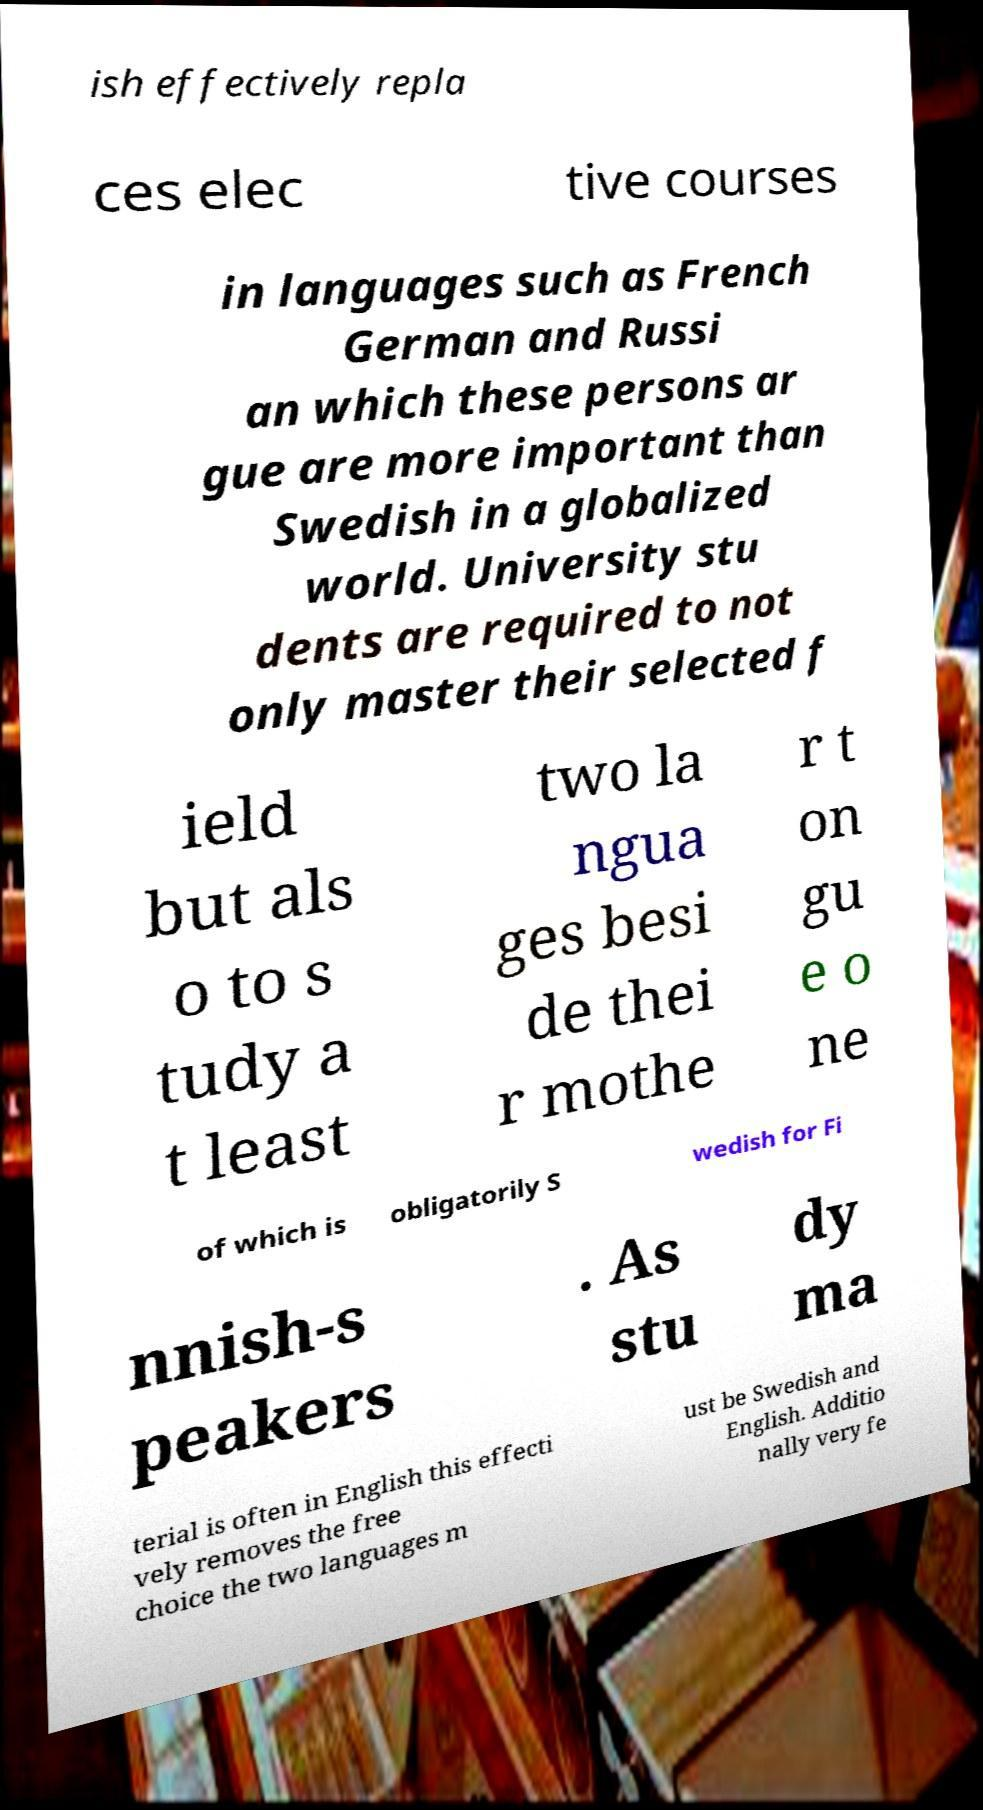There's text embedded in this image that I need extracted. Can you transcribe it verbatim? ish effectively repla ces elec tive courses in languages such as French German and Russi an which these persons ar gue are more important than Swedish in a globalized world. University stu dents are required to not only master their selected f ield but als o to s tudy a t least two la ngua ges besi de thei r mothe r t on gu e o ne of which is obligatorily S wedish for Fi nnish-s peakers . As stu dy ma terial is often in English this effecti vely removes the free choice the two languages m ust be Swedish and English. Additio nally very fe 